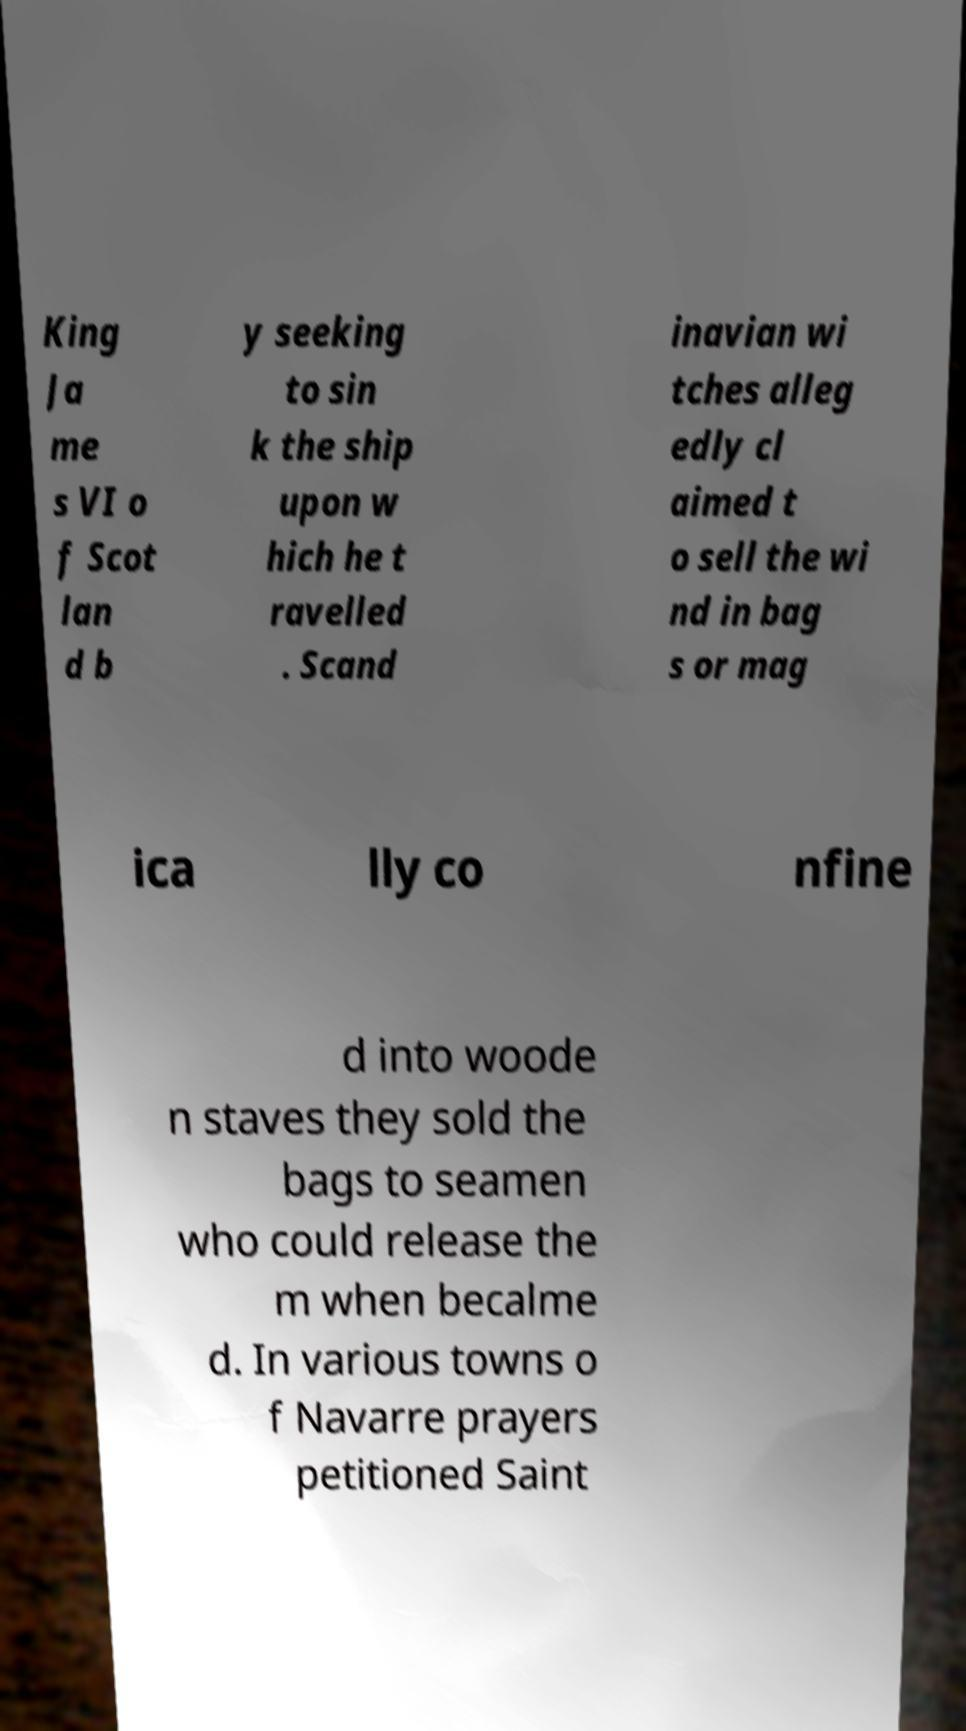Could you assist in decoding the text presented in this image and type it out clearly? King Ja me s VI o f Scot lan d b y seeking to sin k the ship upon w hich he t ravelled . Scand inavian wi tches alleg edly cl aimed t o sell the wi nd in bag s or mag ica lly co nfine d into woode n staves they sold the bags to seamen who could release the m when becalme d. In various towns o f Navarre prayers petitioned Saint 